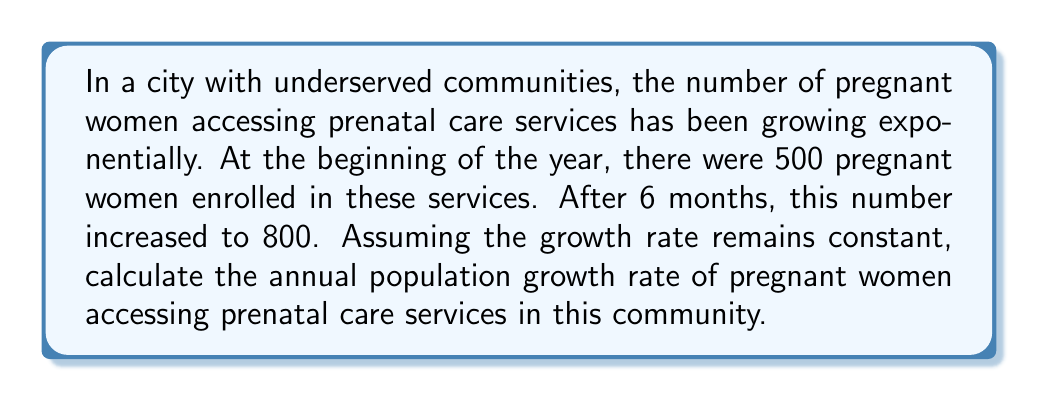Solve this math problem. To solve this problem, we'll use the exponential growth formula:

$$P(t) = P_0 \cdot e^{rt}$$

Where:
$P(t)$ is the population at time $t$
$P_0$ is the initial population
$r$ is the growth rate
$t$ is the time period

We know:
$P_0 = 500$ (initial population)
$P(t) = 800$ (population after 6 months)
$t = 0.5$ years (6 months = 0.5 years)

Let's substitute these values into the equation:

$$800 = 500 \cdot e^{r \cdot 0.5}$$

Now, we need to solve for $r$:

1) Divide both sides by 500:
   $$\frac{800}{500} = e^{r \cdot 0.5}$$

2) Take the natural log of both sides:
   $$\ln(\frac{800}{500}) = \ln(e^{r \cdot 0.5})$$

3) Simplify the right side using the properties of logarithms:
   $$\ln(\frac{800}{500}) = r \cdot 0.5$$

4) Multiply both sides by 2 to isolate $r$:
   $$2 \cdot \ln(\frac{800}{500}) = r$$

5) Calculate the value:
   $$r = 2 \cdot \ln(1.6) \approx 0.9416$$

6) Convert to a percentage:
   $$0.9416 \cdot 100\% \approx 94.16\%$$

Therefore, the annual population growth rate is approximately 94.16%.
Answer: The annual population growth rate of pregnant women accessing prenatal care services in this underserved community is approximately 94.16%. 